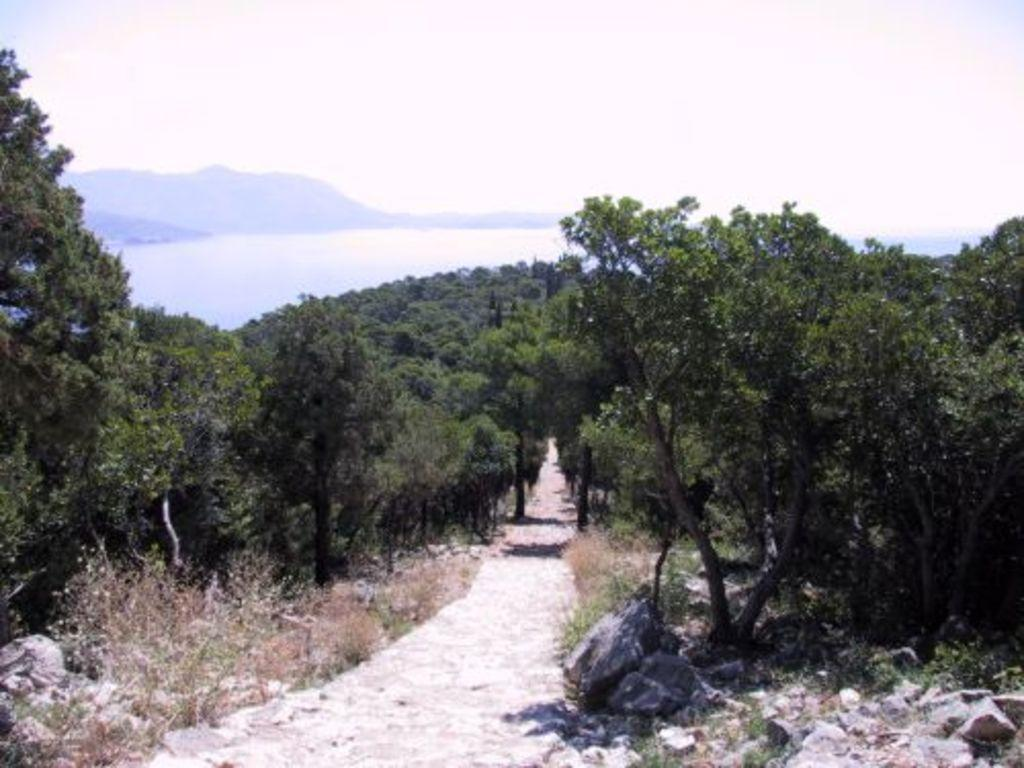What type of path can be seen in the image? There is a path in the image, and it is between trees. What natural feature is located in the middle of the image? There is a river in the middle of the image. What elevated landform is also present in the image? There is a hill in the image, and it is in the middle of the image. What part of the natural environment is visible at the top of the image? The sky is visible at the top of the image. What type of bed can be seen in the image? There is no bed present in the image; it features a path, trees, a river, a hill, and the sky. What type of scale is used to measure the depth of the river in the image? There is no scale present in the image to measure the depth of the river. 